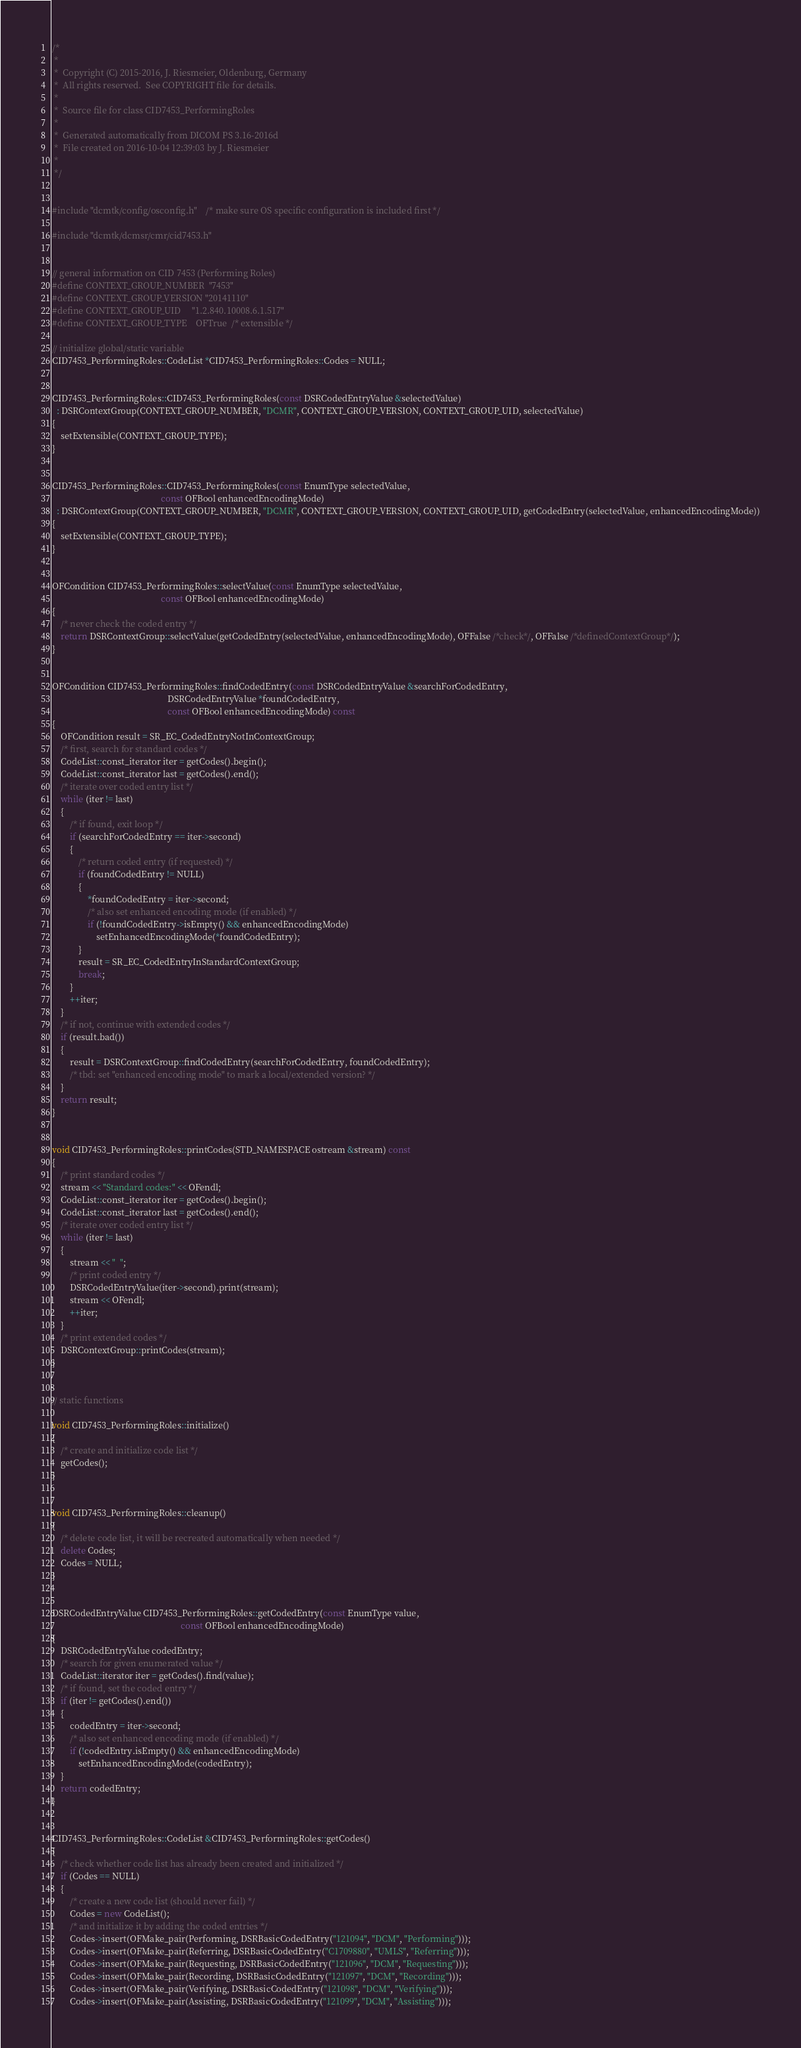Convert code to text. <code><loc_0><loc_0><loc_500><loc_500><_C++_>/*
 *
 *  Copyright (C) 2015-2016, J. Riesmeier, Oldenburg, Germany
 *  All rights reserved.  See COPYRIGHT file for details.
 *
 *  Source file for class CID7453_PerformingRoles
 *
 *  Generated automatically from DICOM PS 3.16-2016d
 *  File created on 2016-10-04 12:39:03 by J. Riesmeier
 *
 */


#include "dcmtk/config/osconfig.h"    /* make sure OS specific configuration is included first */

#include "dcmtk/dcmsr/cmr/cid7453.h"


// general information on CID 7453 (Performing Roles)
#define CONTEXT_GROUP_NUMBER  "7453"
#define CONTEXT_GROUP_VERSION "20141110"
#define CONTEXT_GROUP_UID     "1.2.840.10008.6.1.517"
#define CONTEXT_GROUP_TYPE    OFTrue  /* extensible */

// initialize global/static variable
CID7453_PerformingRoles::CodeList *CID7453_PerformingRoles::Codes = NULL;


CID7453_PerformingRoles::CID7453_PerformingRoles(const DSRCodedEntryValue &selectedValue)
  : DSRContextGroup(CONTEXT_GROUP_NUMBER, "DCMR", CONTEXT_GROUP_VERSION, CONTEXT_GROUP_UID, selectedValue)
{
    setExtensible(CONTEXT_GROUP_TYPE);
}


CID7453_PerformingRoles::CID7453_PerformingRoles(const EnumType selectedValue,
                                                 const OFBool enhancedEncodingMode)
  : DSRContextGroup(CONTEXT_GROUP_NUMBER, "DCMR", CONTEXT_GROUP_VERSION, CONTEXT_GROUP_UID, getCodedEntry(selectedValue, enhancedEncodingMode))
{
    setExtensible(CONTEXT_GROUP_TYPE);
}


OFCondition CID7453_PerformingRoles::selectValue(const EnumType selectedValue,
                                                 const OFBool enhancedEncodingMode)
{
    /* never check the coded entry */
    return DSRContextGroup::selectValue(getCodedEntry(selectedValue, enhancedEncodingMode), OFFalse /*check*/, OFFalse /*definedContextGroup*/);
}


OFCondition CID7453_PerformingRoles::findCodedEntry(const DSRCodedEntryValue &searchForCodedEntry,
                                                    DSRCodedEntryValue *foundCodedEntry,
                                                    const OFBool enhancedEncodingMode) const
{
    OFCondition result = SR_EC_CodedEntryNotInContextGroup;
    /* first, search for standard codes */
    CodeList::const_iterator iter = getCodes().begin();
    CodeList::const_iterator last = getCodes().end();
    /* iterate over coded entry list */
    while (iter != last)
    {
        /* if found, exit loop */
        if (searchForCodedEntry == iter->second)
        {
            /* return coded entry (if requested) */
            if (foundCodedEntry != NULL)
            {
                *foundCodedEntry = iter->second;
                /* also set enhanced encoding mode (if enabled) */
                if (!foundCodedEntry->isEmpty() && enhancedEncodingMode)
                    setEnhancedEncodingMode(*foundCodedEntry);
            }
            result = SR_EC_CodedEntryInStandardContextGroup;
            break;
        }
        ++iter;
    }
    /* if not, continue with extended codes */
    if (result.bad())
    {
        result = DSRContextGroup::findCodedEntry(searchForCodedEntry, foundCodedEntry);
        /* tbd: set "enhanced encoding mode" to mark a local/extended version? */
    }
    return result;
}


void CID7453_PerformingRoles::printCodes(STD_NAMESPACE ostream &stream) const
{
    /* print standard codes */
    stream << "Standard codes:" << OFendl;
    CodeList::const_iterator iter = getCodes().begin();
    CodeList::const_iterator last = getCodes().end();
    /* iterate over coded entry list */
    while (iter != last)
    {
        stream << "  ";
        /* print coded entry */
        DSRCodedEntryValue(iter->second).print(stream);
        stream << OFendl;
        ++iter;
    }
    /* print extended codes */
    DSRContextGroup::printCodes(stream);
}


// static functions

void CID7453_PerformingRoles::initialize()
{
    /* create and initialize code list */
    getCodes();
}


void CID7453_PerformingRoles::cleanup()
{
    /* delete code list, it will be recreated automatically when needed */
    delete Codes;
    Codes = NULL;
}


DSRCodedEntryValue CID7453_PerformingRoles::getCodedEntry(const EnumType value,
                                                          const OFBool enhancedEncodingMode)
{
    DSRCodedEntryValue codedEntry;
    /* search for given enumerated value */
    CodeList::iterator iter = getCodes().find(value);
    /* if found, set the coded entry */
    if (iter != getCodes().end())
    {
        codedEntry = iter->second;
        /* also set enhanced encoding mode (if enabled) */
        if (!codedEntry.isEmpty() && enhancedEncodingMode)
            setEnhancedEncodingMode(codedEntry);
    }
    return codedEntry;
}


CID7453_PerformingRoles::CodeList &CID7453_PerformingRoles::getCodes()
{
    /* check whether code list has already been created and initialized */
    if (Codes == NULL)
    {
        /* create a new code list (should never fail) */
        Codes = new CodeList();
        /* and initialize it by adding the coded entries */
        Codes->insert(OFMake_pair(Performing, DSRBasicCodedEntry("121094", "DCM", "Performing")));
        Codes->insert(OFMake_pair(Referring, DSRBasicCodedEntry("C1709880", "UMLS", "Referring")));
        Codes->insert(OFMake_pair(Requesting, DSRBasicCodedEntry("121096", "DCM", "Requesting")));
        Codes->insert(OFMake_pair(Recording, DSRBasicCodedEntry("121097", "DCM", "Recording")));
        Codes->insert(OFMake_pair(Verifying, DSRBasicCodedEntry("121098", "DCM", "Verifying")));
        Codes->insert(OFMake_pair(Assisting, DSRBasicCodedEntry("121099", "DCM", "Assisting")));</code> 